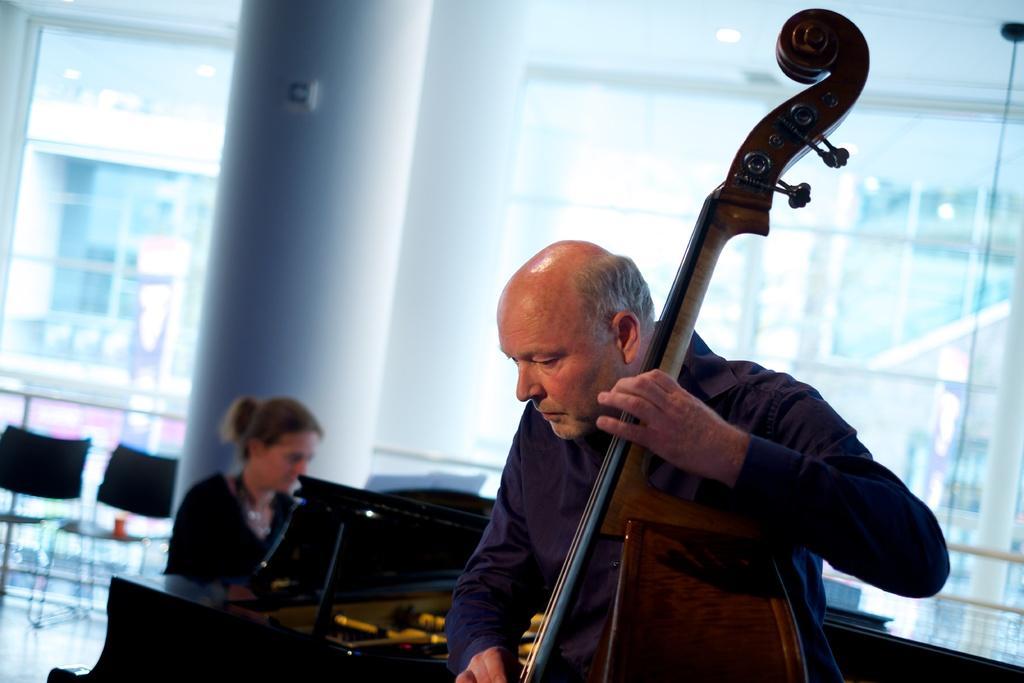Describe this image in one or two sentences. This picture shows a man playing a violin and a woman playing a piano and we see couple of chairs 